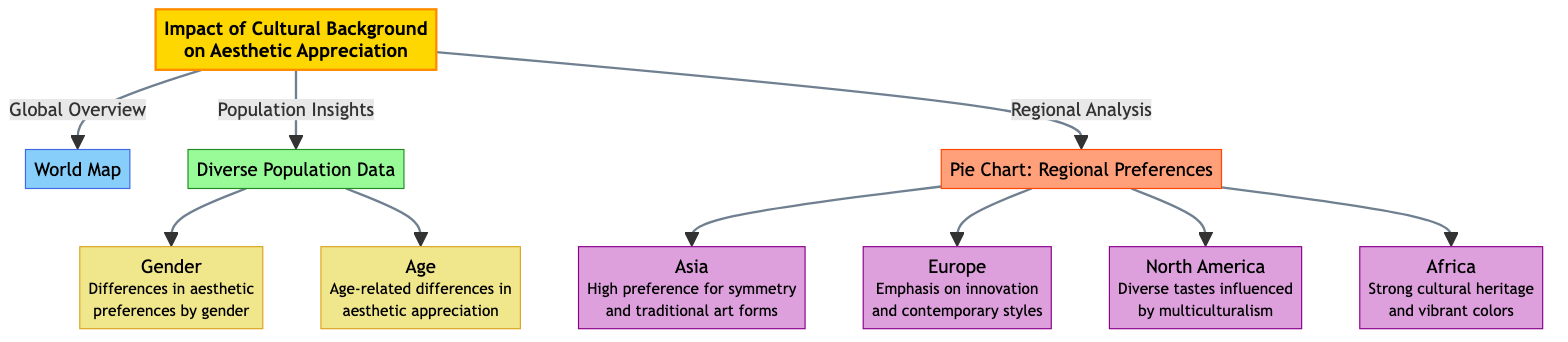What is the main topic of the diagram? The main topic is clearly indicated in node 1, labeled "Impact of Cultural Background on Aesthetic Appreciation." This title summarizes the overarching theme of the visual representation.
Answer: Impact of Cultural Background on Aesthetic Appreciation How many regions are analyzed in the pie chart? The pie chart details four specific regions: Asia, Europe, North America, and Africa, which can be directly counted from the connections leading from node 4 in the diagram.
Answer: 4 What does Asia emphasize in aesthetic appreciation? The related sub-node under the pie chart for Asia states, "High preference for symmetry and traditional art forms," directly providing this information.
Answer: High preference for symmetry and traditional art forms What influences North America's diverse aesthetic tastes? The sub-node for North America indicates that aesthetic preferences are influenced by multiculturalism, capturing the essence of the region's aesthetic appreciation context.
Answer: Multiculturalism What demographic factors are considered in the diverse population data? Two specific demographic factors are shown: gender and age, which can be identified directly in the connections from node 3 as they are both mentioned as sub-nodes.
Answer: Gender, Age Which region places emphasis on innovation and contemporary styles? The node for Europe specifies that it places emphasis on "innovation and contemporary styles," providing a direct and concise answer regarding its aesthetic focus.
Answer: Europe What color scheme is used for the main topic? The class definition for the main topic (node 1) describes a fill color of #FFD700 (gold), which defines the color scheme applied to that particular section of the diagram.
Answer: Gold How does the diagram relate regional analysis to aesthetic preferences? The structure of the diagram shows that node 1 links to node 4 (the pie chart), indicating that regional analysis is a key aspect of understanding aesthetic preferences, which reinforces the content's connection.
Answer: Regional Analysis links to Aesthetic Preferences 